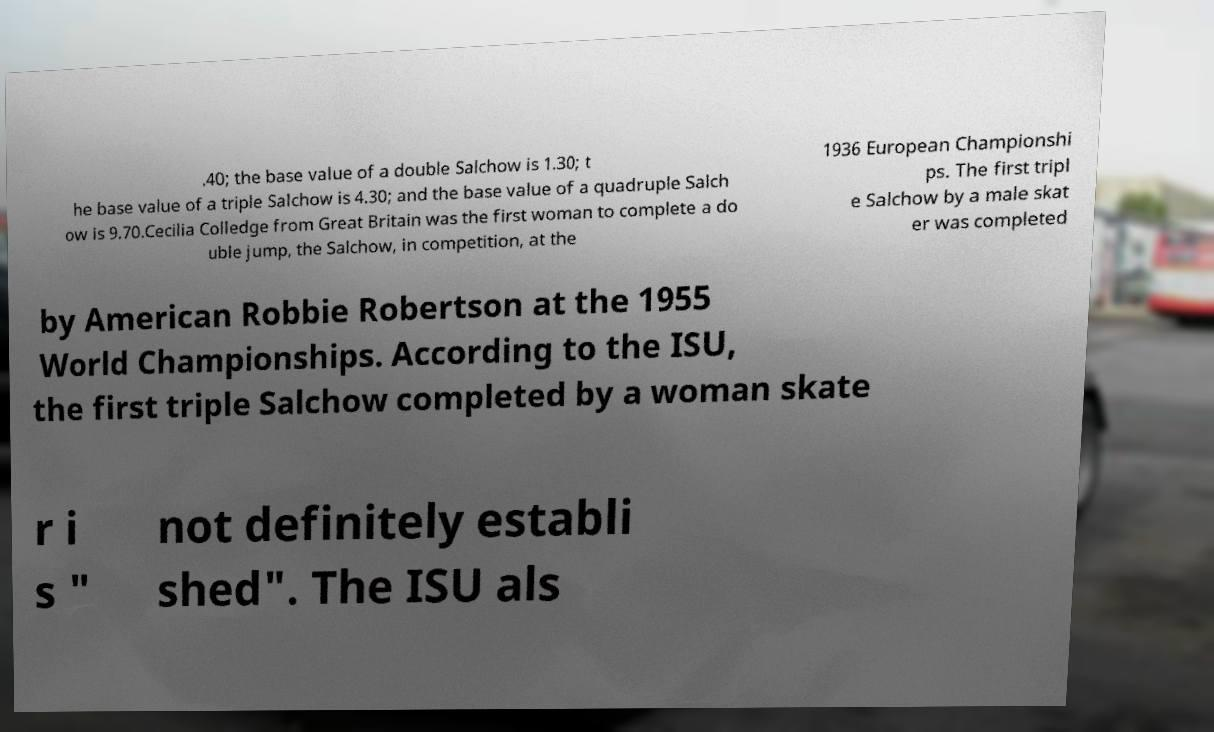Can you accurately transcribe the text from the provided image for me? .40; the base value of a double Salchow is 1.30; t he base value of a triple Salchow is 4.30; and the base value of a quadruple Salch ow is 9.70.Cecilia Colledge from Great Britain was the first woman to complete a do uble jump, the Salchow, in competition, at the 1936 European Championshi ps. The first tripl e Salchow by a male skat er was completed by American Robbie Robertson at the 1955 World Championships. According to the ISU, the first triple Salchow completed by a woman skate r i s " not definitely establi shed". The ISU als 